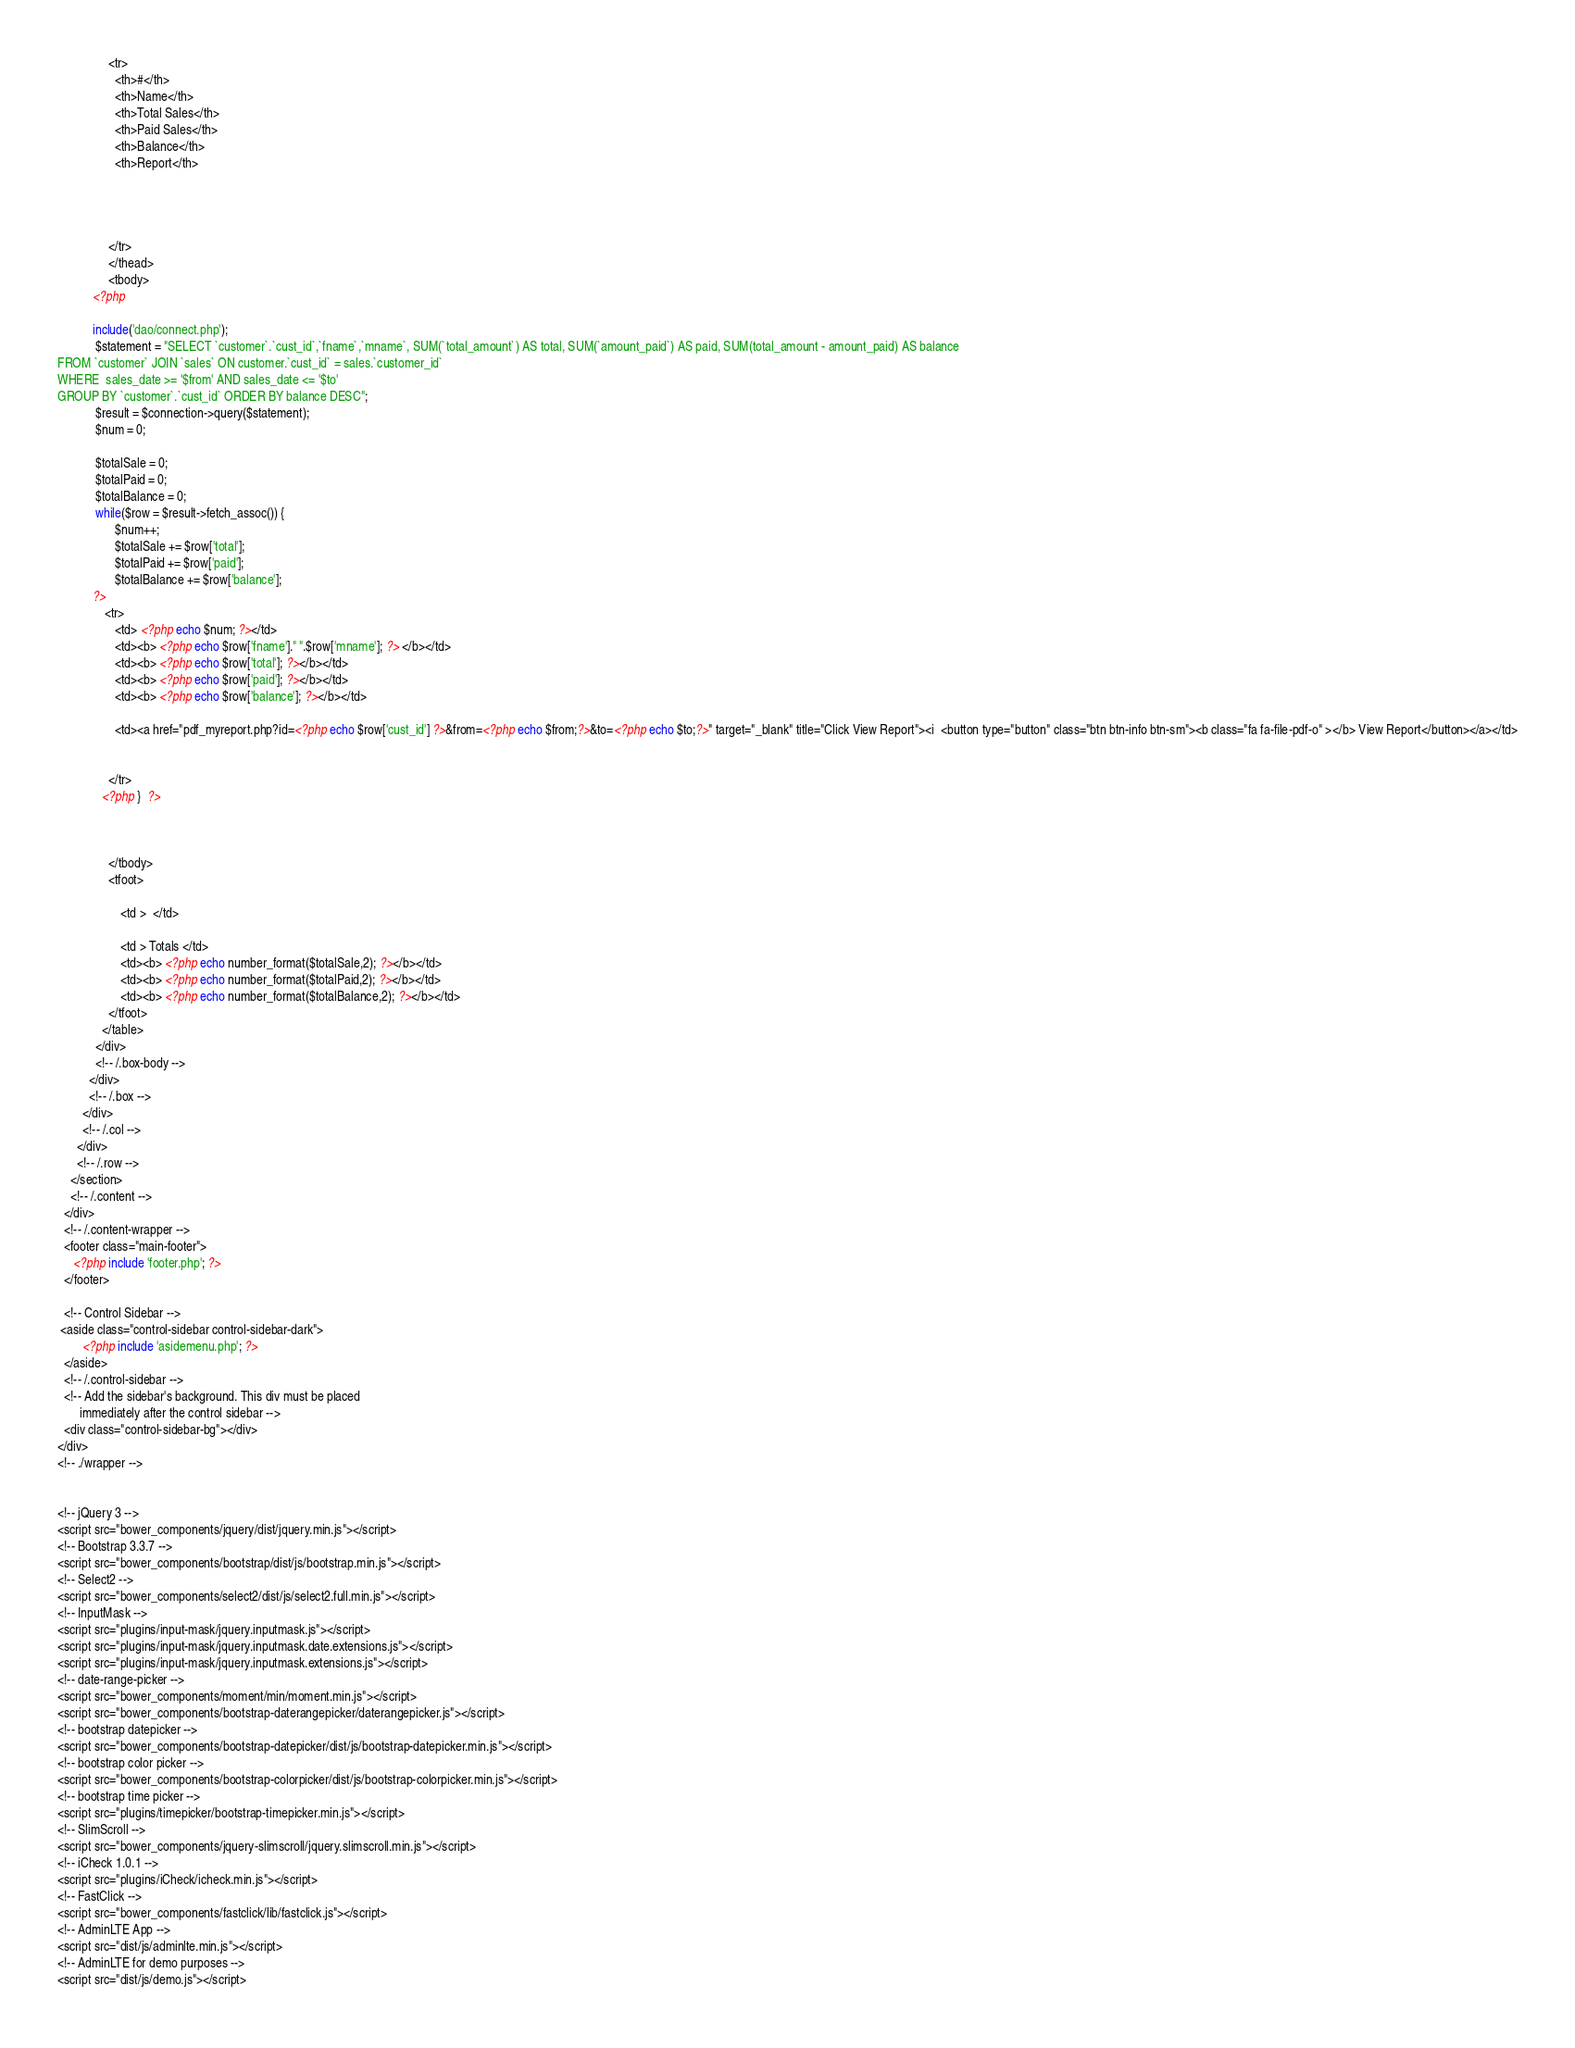Convert code to text. <code><loc_0><loc_0><loc_500><loc_500><_PHP_>                <tr>
                  <th>#</th>
                  <th>Name</th>
                  <th>Total Sales</th>
                  <th>Paid Sales</th>
                  <th>Balance</th>
                  <th>Report</th>
                
                  
               
                  
                </tr>
                </thead>
                <tbody>
           <?php 
           
           include('dao/connect.php');
            $statement = "SELECT `customer`.`cust_id`,`fname`,`mname`, SUM(`total_amount`) AS total, SUM(`amount_paid`) AS paid, SUM(total_amount - amount_paid) AS balance 
FROM `customer` JOIN `sales` ON customer.`cust_id` = sales.`customer_id`
WHERE  sales_date >= '$from' AND sales_date <= '$to'
GROUP BY `customer`.`cust_id` ORDER BY balance DESC";
            $result = $connection->query($statement);
            $num = 0;
            
            $totalSale = 0;
            $totalPaid = 0;
            $totalBalance = 0;
            while($row = $result->fetch_assoc()) {
                  $num++;
                  $totalSale += $row['total'];
                  $totalPaid += $row['paid'];
                  $totalBalance += $row['balance'];
           ?>    
               <tr>
                  <td> <?php echo $num; ?></td>
                  <td><b> <?php echo $row['fname']." ".$row['mname']; ?> </b></td>
                  <td><b> <?php echo $row['total']; ?></b></td>
                  <td><b> <?php echo $row['paid']; ?></b></td>
                  <td><b> <?php echo $row['balance']; ?></b></td>
                  
                  <td><a href="pdf_myreport.php?id=<?php echo $row['cust_id'] ?>&from=<?php echo $from;?>&to=<?php echo $to;?>" target="_blank" title="Click View Report"><i  <button type="button" class="btn btn-info btn-sm"><b class="fa fa-file-pdf-o" ></b> View Report</button></a></td>
                
                 
                </tr>
              <?php }  ?>    
                
                  
                
                </tbody>
                <tfoot>
                   
                    <td >  </td>
                    
                    <td > Totals </td>
                    <td><b> <?php echo number_format($totalSale,2); ?></b></td>
                    <td><b> <?php echo number_format($totalPaid,2); ?></b></td>
                    <td><b> <?php echo number_format($totalBalance,2); ?></b></td>
                </tfoot>
              </table>
            </div>
            <!-- /.box-body -->
          </div>
          <!-- /.box -->
        </div>
        <!-- /.col -->
      </div>
      <!-- /.row -->
    </section>
    <!-- /.content -->
  </div>
  <!-- /.content-wrapper -->
  <footer class="main-footer">
     <?php include 'footer.php'; ?>
  </footer>

  <!-- Control Sidebar -->
 <aside class="control-sidebar control-sidebar-dark">
        <?php include 'asidemenu.php'; ?>
  </aside>
  <!-- /.control-sidebar -->
  <!-- Add the sidebar's background. This div must be placed
       immediately after the control sidebar -->
  <div class="control-sidebar-bg"></div>
</div>
<!-- ./wrapper -->


<!-- jQuery 3 -->
<script src="bower_components/jquery/dist/jquery.min.js"></script>
<!-- Bootstrap 3.3.7 -->
<script src="bower_components/bootstrap/dist/js/bootstrap.min.js"></script>
<!-- Select2 -->
<script src="bower_components/select2/dist/js/select2.full.min.js"></script>
<!-- InputMask -->
<script src="plugins/input-mask/jquery.inputmask.js"></script>
<script src="plugins/input-mask/jquery.inputmask.date.extensions.js"></script>
<script src="plugins/input-mask/jquery.inputmask.extensions.js"></script>
<!-- date-range-picker -->
<script src="bower_components/moment/min/moment.min.js"></script>
<script src="bower_components/bootstrap-daterangepicker/daterangepicker.js"></script>
<!-- bootstrap datepicker -->
<script src="bower_components/bootstrap-datepicker/dist/js/bootstrap-datepicker.min.js"></script>
<!-- bootstrap color picker -->
<script src="bower_components/bootstrap-colorpicker/dist/js/bootstrap-colorpicker.min.js"></script>
<!-- bootstrap time picker -->
<script src="plugins/timepicker/bootstrap-timepicker.min.js"></script>
<!-- SlimScroll -->
<script src="bower_components/jquery-slimscroll/jquery.slimscroll.min.js"></script>
<!-- iCheck 1.0.1 -->
<script src="plugins/iCheck/icheck.min.js"></script>
<!-- FastClick -->
<script src="bower_components/fastclick/lib/fastclick.js"></script>
<!-- AdminLTE App -->
<script src="dist/js/adminlte.min.js"></script>
<!-- AdminLTE for demo purposes -->
<script src="dist/js/demo.js"></script></code> 